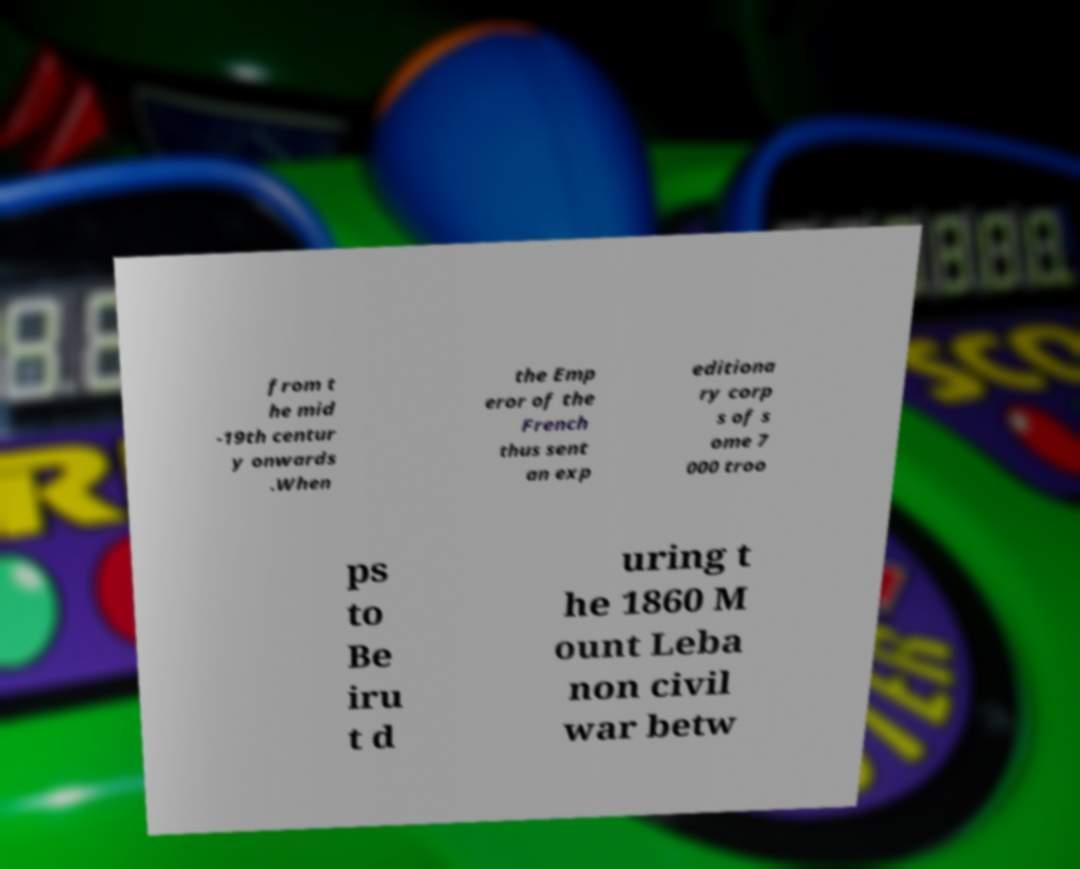Please identify and transcribe the text found in this image. from t he mid -19th centur y onwards .When the Emp eror of the French thus sent an exp editiona ry corp s of s ome 7 000 troo ps to Be iru t d uring t he 1860 M ount Leba non civil war betw 